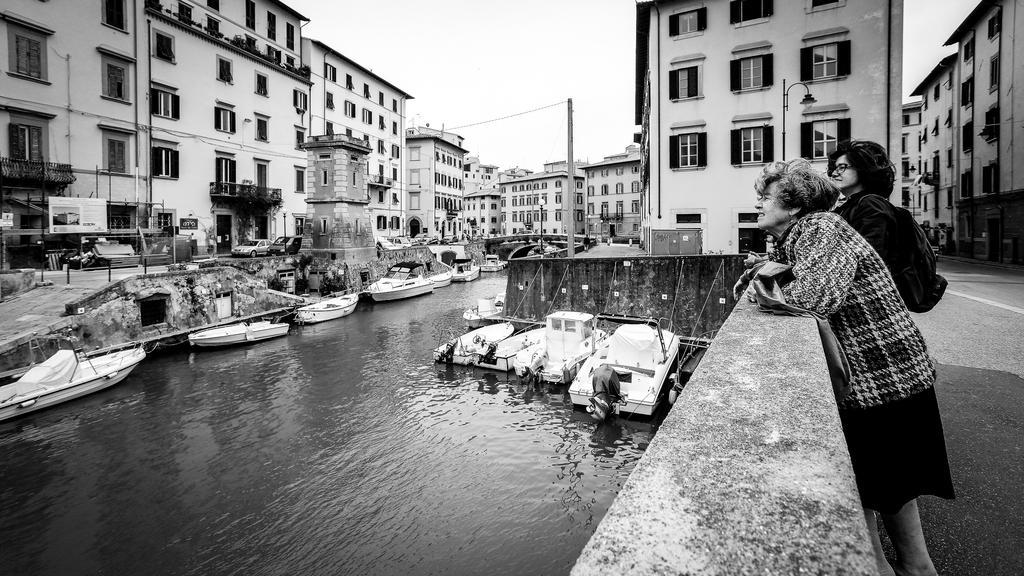Describe this image in one or two sentences. In this image at the bottom there is a river, in that river there are some boats. In the background there are some buildings, houses, poles, trees and some vehicles on the road. On the right side there are two women who are standing and watching something. 